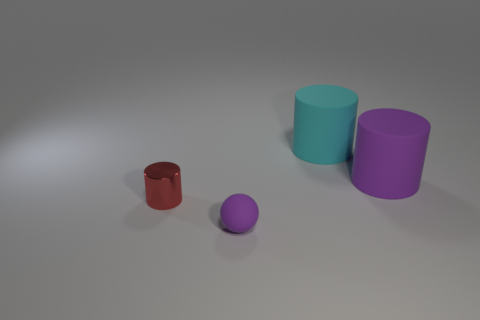Are there any tiny objects of the same color as the matte ball?
Ensure brevity in your answer.  No. Do the small object left of the small rubber sphere and the small matte thing have the same color?
Make the answer very short. No. What number of objects are things that are to the left of the small ball or large cyan rubber things?
Your answer should be very brief. 2. Are there any large cyan cylinders in front of the tiny matte sphere?
Ensure brevity in your answer.  No. There is a big cylinder that is the same color as the small ball; what material is it?
Provide a succinct answer. Rubber. Do the big object that is in front of the cyan matte cylinder and the cyan cylinder have the same material?
Keep it short and to the point. Yes. There is a thing to the left of the tiny thing that is right of the shiny cylinder; is there a purple ball that is behind it?
Make the answer very short. No. What number of blocks are large purple shiny things or small purple matte things?
Offer a terse response. 0. What is the material of the large object that is right of the cyan cylinder?
Give a very brief answer. Rubber. There is a object that is the same color as the small matte sphere; what is its size?
Your answer should be very brief. Large. 